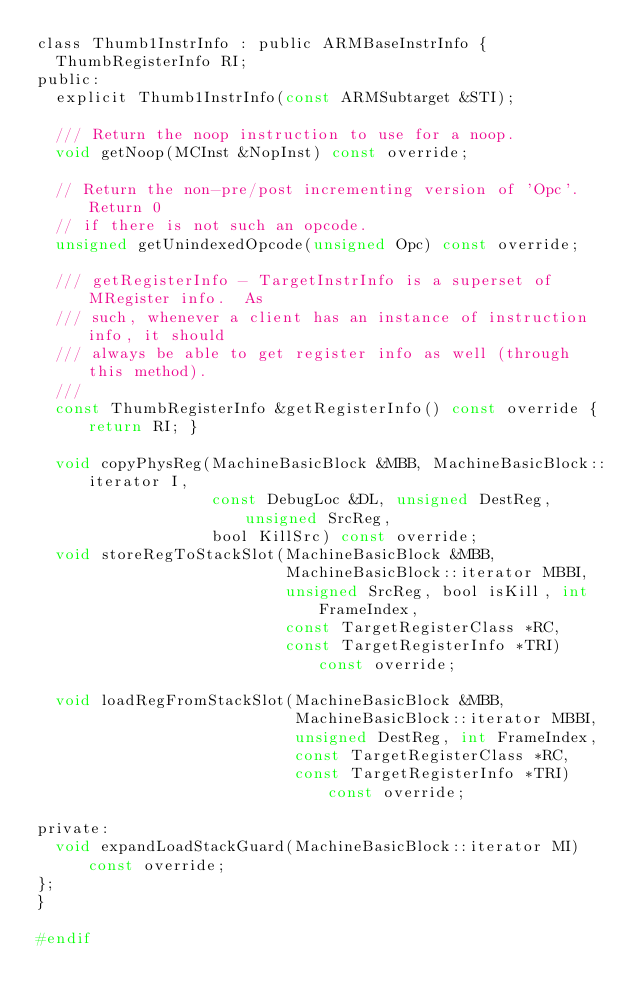<code> <loc_0><loc_0><loc_500><loc_500><_C_>class Thumb1InstrInfo : public ARMBaseInstrInfo {
  ThumbRegisterInfo RI;
public:
  explicit Thumb1InstrInfo(const ARMSubtarget &STI);

  /// Return the noop instruction to use for a noop.
  void getNoop(MCInst &NopInst) const override;

  // Return the non-pre/post incrementing version of 'Opc'. Return 0
  // if there is not such an opcode.
  unsigned getUnindexedOpcode(unsigned Opc) const override;

  /// getRegisterInfo - TargetInstrInfo is a superset of MRegister info.  As
  /// such, whenever a client has an instance of instruction info, it should
  /// always be able to get register info as well (through this method).
  ///
  const ThumbRegisterInfo &getRegisterInfo() const override { return RI; }

  void copyPhysReg(MachineBasicBlock &MBB, MachineBasicBlock::iterator I,
                   const DebugLoc &DL, unsigned DestReg, unsigned SrcReg,
                   bool KillSrc) const override;
  void storeRegToStackSlot(MachineBasicBlock &MBB,
                           MachineBasicBlock::iterator MBBI,
                           unsigned SrcReg, bool isKill, int FrameIndex,
                           const TargetRegisterClass *RC,
                           const TargetRegisterInfo *TRI) const override;

  void loadRegFromStackSlot(MachineBasicBlock &MBB,
                            MachineBasicBlock::iterator MBBI,
                            unsigned DestReg, int FrameIndex,
                            const TargetRegisterClass *RC,
                            const TargetRegisterInfo *TRI) const override;

private:
  void expandLoadStackGuard(MachineBasicBlock::iterator MI) const override;
};
}

#endif
</code> 